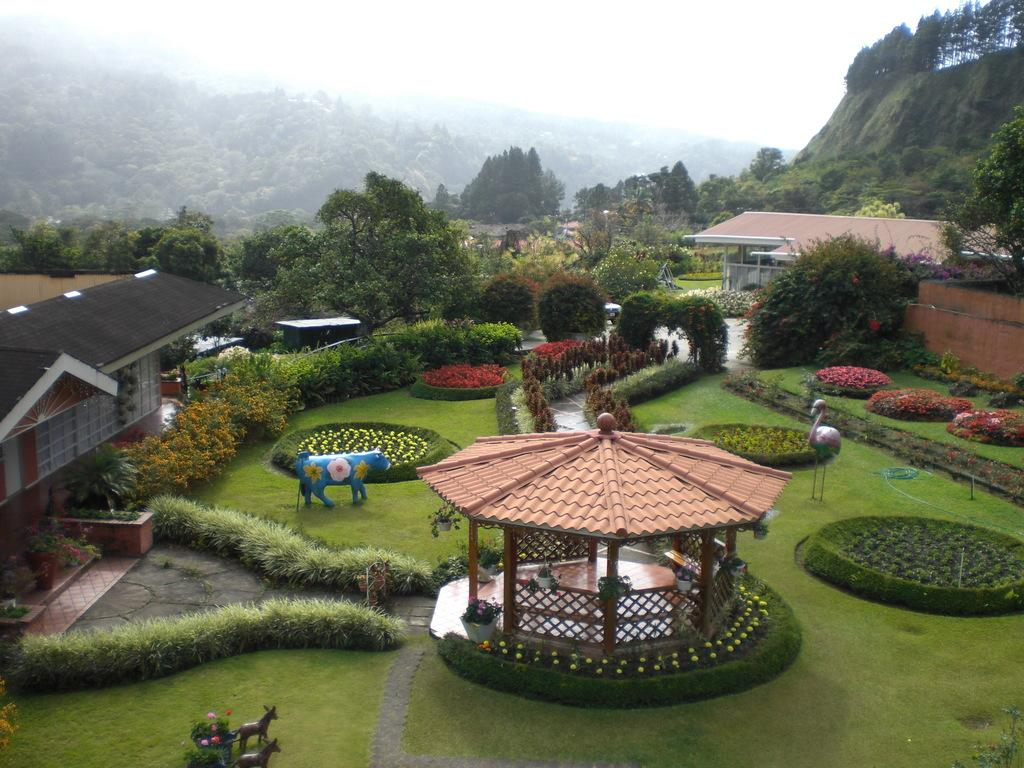What type of structure can be seen in the image? There is a shed in the image. What type of plants are present in the image? There are house plants and flowers in the image. What type of decorative items can be seen in the image? There are statues in the image. What type of vegetation is present in the image? There are trees and grass in the image. What type of residential structures are present in the image? There are houses in the image. What type of paths are present in the image? There are paths in the image. What type of natural landmarks are present in the image? There are mountains in the image. What can be seen in the background of the image? The sky is visible in the background of the image. How many babies are participating in the feast in the image? There is no feast or babies present in the image. What type of muscle is visible on the statues in the image? There are no muscles visible on the statues in the image, as they are not human figures. 